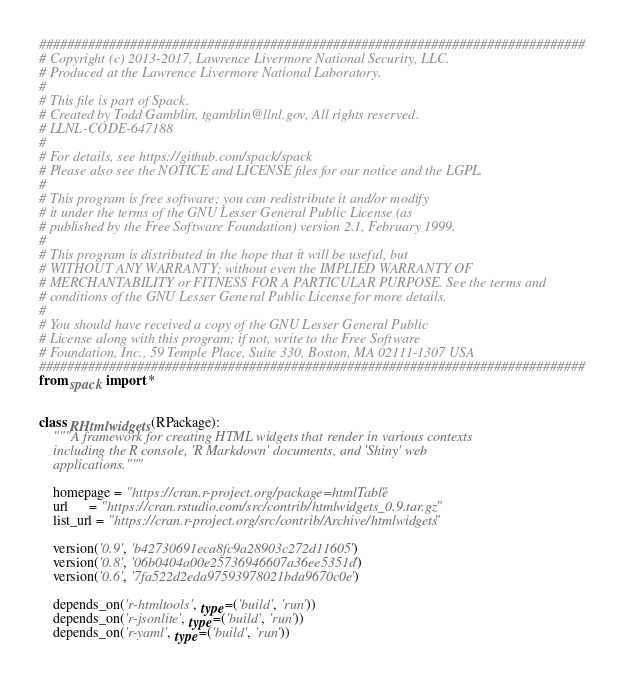Convert code to text. <code><loc_0><loc_0><loc_500><loc_500><_Python_>##############################################################################
# Copyright (c) 2013-2017, Lawrence Livermore National Security, LLC.
# Produced at the Lawrence Livermore National Laboratory.
#
# This file is part of Spack.
# Created by Todd Gamblin, tgamblin@llnl.gov, All rights reserved.
# LLNL-CODE-647188
#
# For details, see https://github.com/spack/spack
# Please also see the NOTICE and LICENSE files for our notice and the LGPL.
#
# This program is free software; you can redistribute it and/or modify
# it under the terms of the GNU Lesser General Public License (as
# published by the Free Software Foundation) version 2.1, February 1999.
#
# This program is distributed in the hope that it will be useful, but
# WITHOUT ANY WARRANTY; without even the IMPLIED WARRANTY OF
# MERCHANTABILITY or FITNESS FOR A PARTICULAR PURPOSE. See the terms and
# conditions of the GNU Lesser General Public License for more details.
#
# You should have received a copy of the GNU Lesser General Public
# License along with this program; if not, write to the Free Software
# Foundation, Inc., 59 Temple Place, Suite 330, Boston, MA 02111-1307 USA
##############################################################################
from spack import *


class RHtmlwidgets(RPackage):
    """A framework for creating HTML widgets that render in various contexts
    including the R console, 'R Markdown' documents, and 'Shiny' web
    applications."""

    homepage = "https://cran.r-project.org/package=htmlTable"
    url      = "https://cran.rstudio.com/src/contrib/htmlwidgets_0.9.tar.gz"
    list_url = "https://cran.r-project.org/src/contrib/Archive/htmlwidgets"

    version('0.9', 'b42730691eca8fc9a28903c272d11605')
    version('0.8', '06b0404a00e25736946607a36ee5351d')
    version('0.6', '7fa522d2eda97593978021bda9670c0e')

    depends_on('r-htmltools', type=('build', 'run'))
    depends_on('r-jsonlite', type=('build', 'run'))
    depends_on('r-yaml', type=('build', 'run'))
</code> 